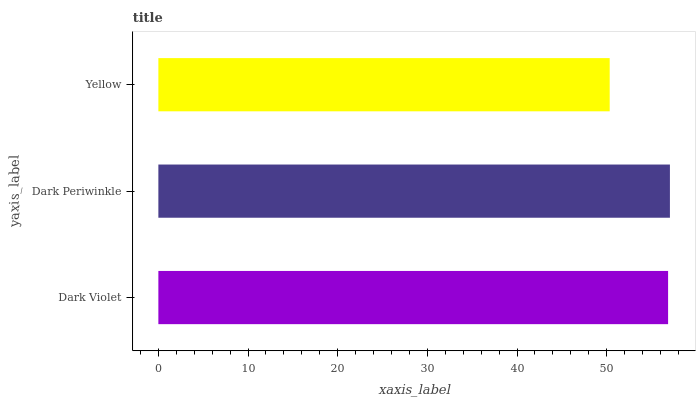Is Yellow the minimum?
Answer yes or no. Yes. Is Dark Periwinkle the maximum?
Answer yes or no. Yes. Is Dark Periwinkle the minimum?
Answer yes or no. No. Is Yellow the maximum?
Answer yes or no. No. Is Dark Periwinkle greater than Yellow?
Answer yes or no. Yes. Is Yellow less than Dark Periwinkle?
Answer yes or no. Yes. Is Yellow greater than Dark Periwinkle?
Answer yes or no. No. Is Dark Periwinkle less than Yellow?
Answer yes or no. No. Is Dark Violet the high median?
Answer yes or no. Yes. Is Dark Violet the low median?
Answer yes or no. Yes. Is Dark Periwinkle the high median?
Answer yes or no. No. Is Dark Periwinkle the low median?
Answer yes or no. No. 